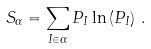Convert formula to latex. <formula><loc_0><loc_0><loc_500><loc_500>S _ { \alpha } = \sum _ { I \in \alpha } P _ { I } \ln \left ( P _ { I } \right ) \, .</formula> 